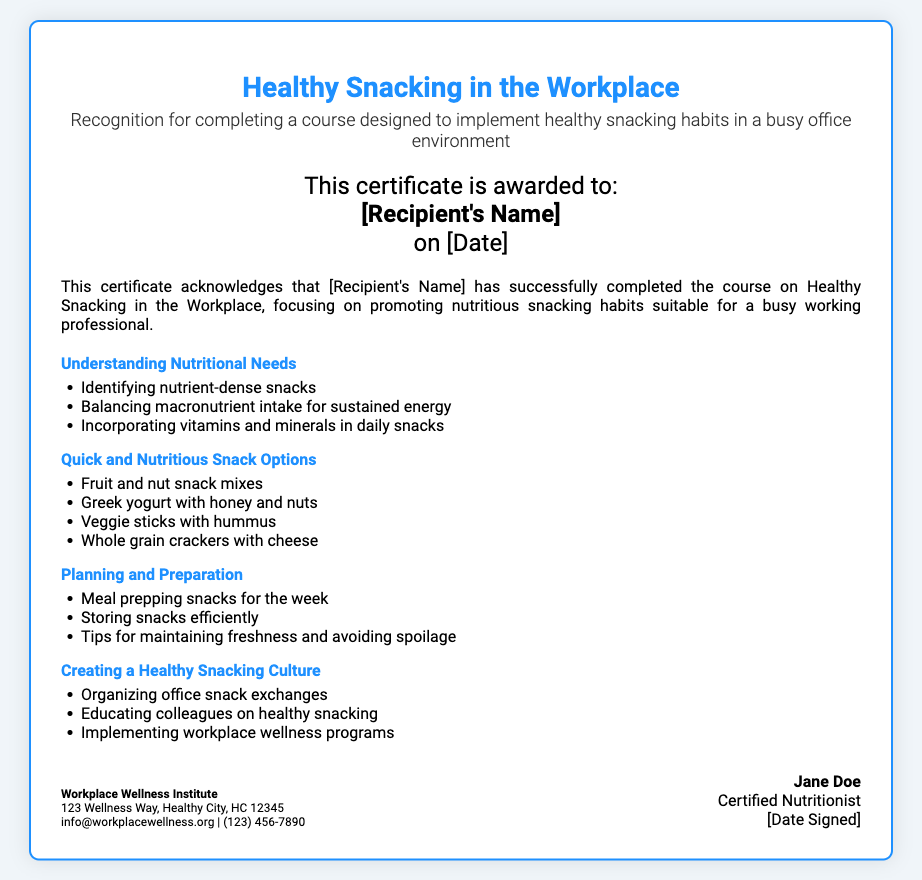What is the title of the certificate? The title of the certificate is clearly stated at the top of the document.
Answer: Healthy Snacking in the Workplace Who is the certificate awarded to? The specific recipient's name is mentioned in the certificate section.
Answer: [Recipient's Name] What is one of the topics covered under "Quick and Nutritious Snack Options"? This is found in the course outline section detailing specific modules.
Answer: Fruit and nut snack mixes Which organization issued the certificate? The footer of the document lists the organization that issues the certificate.
Answer: Workplace Wellness Institute What is the contact email provided on the certificate? The contact information is located in the footer section of the document.
Answer: info@workplacewellness.org How many modules are outlined in the course? The number of modules is determined by counting the module headings in the course outline.
Answer: 4 What is one recommendation from the "Planning and Preparation" module? This can be found listed under the related topics in the course outline.
Answer: Meal prepping snacks for the week Who signed the certificate? The signature section of the footer identifies the person who signed the certificate.
Answer: Jane Doe On what date is the certificate awarded? The date awarded is written in the middle section where the recipient's information is found.
Answer: [Date] 